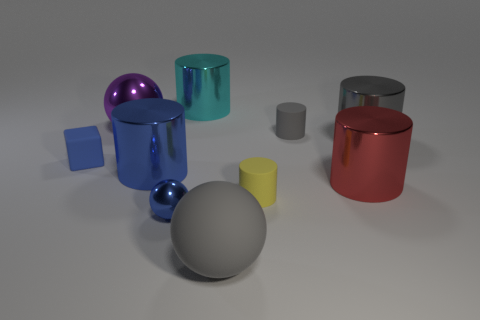What shape is the big metallic object that is in front of the large purple ball and left of the big red metallic object?
Keep it short and to the point. Cylinder. What number of red objects are either rubber things or cylinders?
Ensure brevity in your answer.  1. There is a blue metal thing in front of the red cylinder; is its size the same as the gray cylinder on the right side of the red metal thing?
Provide a short and direct response. No. How many objects are objects or big gray cylinders?
Make the answer very short. 10. Are there any other objects of the same shape as the large blue object?
Offer a terse response. Yes. Are there fewer shiny cylinders than small blue metal balls?
Offer a very short reply. No. Is the shape of the cyan metallic thing the same as the red object?
Your response must be concise. Yes. What number of things are either blue balls or large objects to the right of the large cyan cylinder?
Provide a short and direct response. 4. How many small gray rubber cylinders are there?
Offer a terse response. 1. Is there a gray sphere that has the same size as the gray metallic object?
Ensure brevity in your answer.  Yes. 